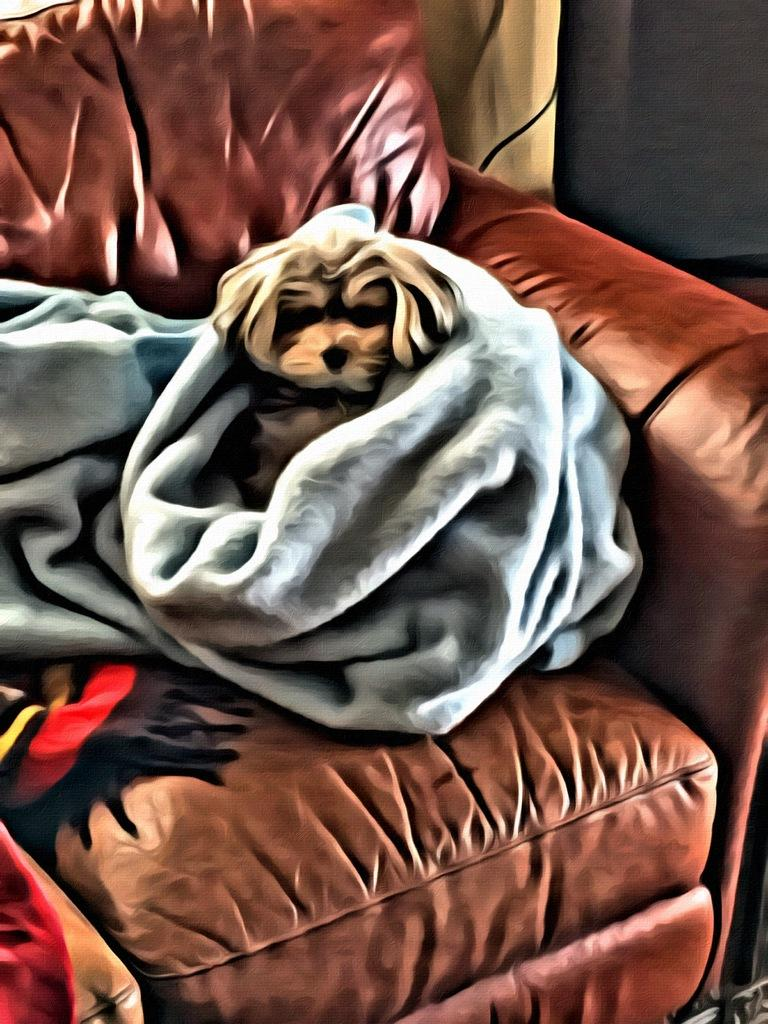What type of furniture is in the image? There is a couch in the image. What is sitting on the couch? A dog is sitting on the couch. What else can be seen in the image? There is a blanket in the image. What type of screw is holding the dog's apparel together in the image? There is no screw or apparel visible on the dog in the image. What type of club is the dog holding in the image? There is no club visible in the image; the dog is simply sitting on the couch. 